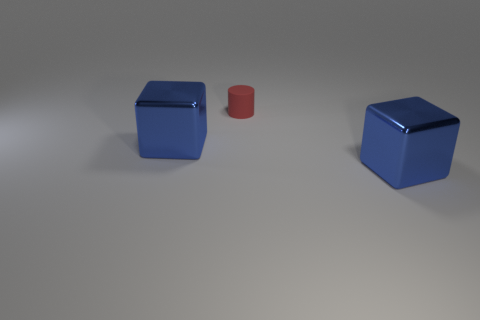Add 1 cylinders. How many objects exist? 4 Subtract 0 gray cylinders. How many objects are left? 3 Subtract all cubes. How many objects are left? 1 Subtract all green blocks. Subtract all yellow balls. How many blocks are left? 2 Subtract all metal things. Subtract all tiny matte objects. How many objects are left? 0 Add 1 tiny red cylinders. How many tiny red cylinders are left? 2 Add 2 blue shiny objects. How many blue shiny objects exist? 4 